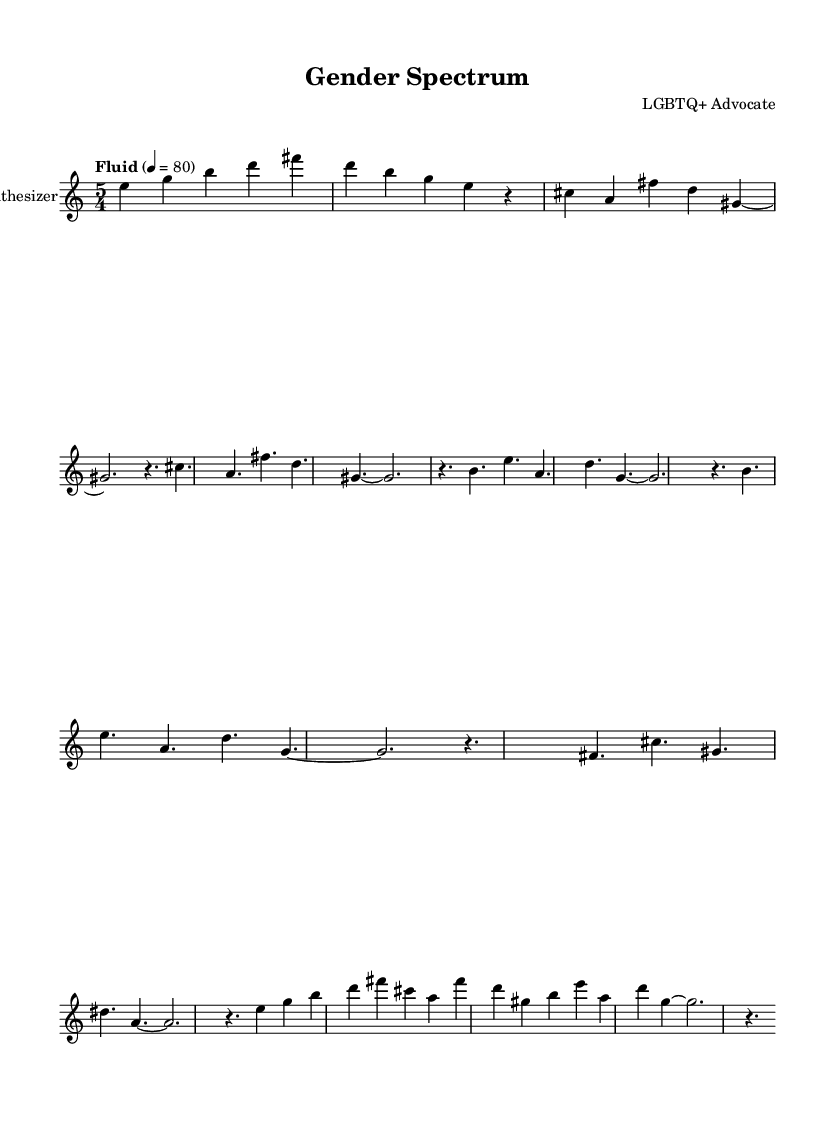What is the time signature of this music? The time signature is indicated at the beginning of the piece, which shows a 5/4 time signature. This indicates that there are five beats in each measure and a quarter note gets one beat.
Answer: 5/4 What is the tempo marking for this piece? The tempo is marked as "Fluid" with a metronome marking of 80 beats per minute, which is found right after the time signature. This gives performers an idea of the speed and character of the piece.
Answer: Fluid, 80 How many measures are there in the chorus section? By looking at the notation and counting the measures from the beginning of the chorus, we can see there are four measures in total.
Answer: 4 What is the highest note in the verse? Analyzing the verse section, the highest note is indicated by "fis'", which is the note F sharp in the octave above middle C. This can be identified within the related melodic line.
Answer: F sharp What instrument is specified for this score? The instrument is specified at the beginning of the score as "Synthesizer," which tells us the performer should play the piece using a synthesizer. This is indicated in the staff's instrument name.
Answer: Synthesizer What type of musical form does this piece exhibit based on the structure? The piece exhibits a common verse-chorus form, which consists of alternating verses and choruses followed by a bridge, a typical structure in many songs. This can be determined by examining the repeated sections in the score.
Answer: Verse-chorus 